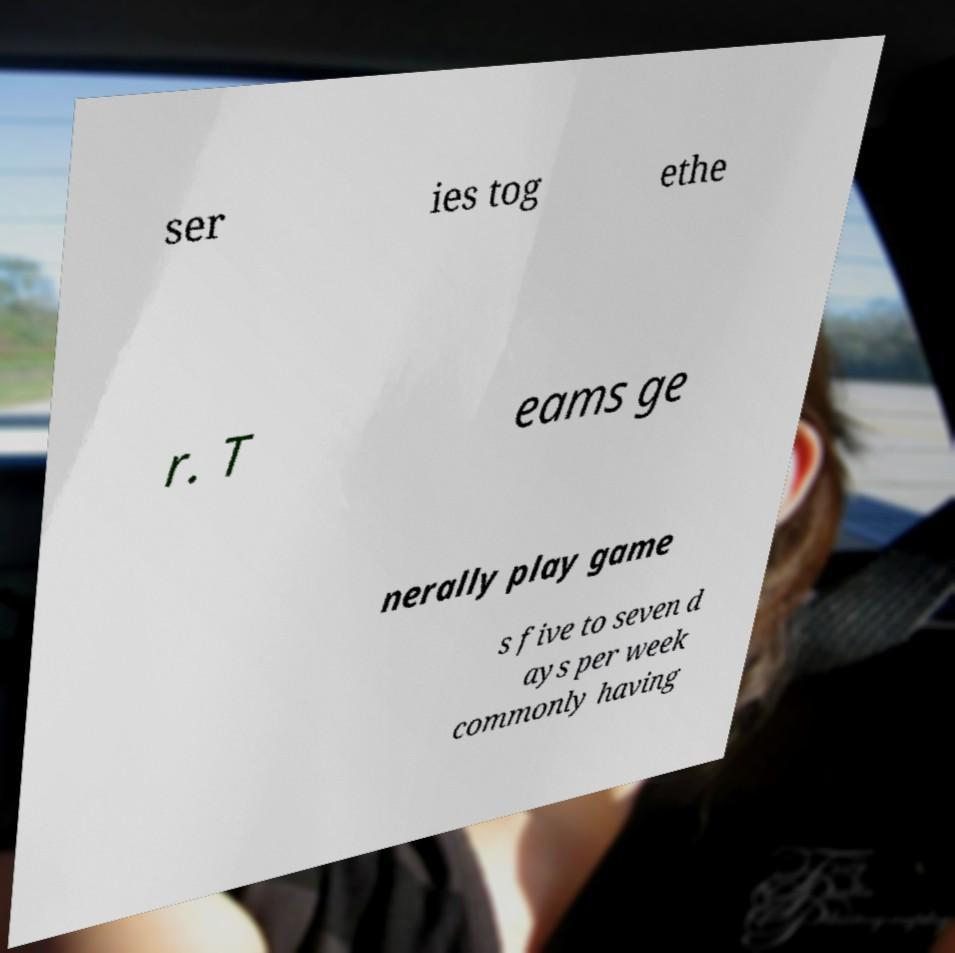Please read and relay the text visible in this image. What does it say? ser ies tog ethe r. T eams ge nerally play game s five to seven d ays per week commonly having 